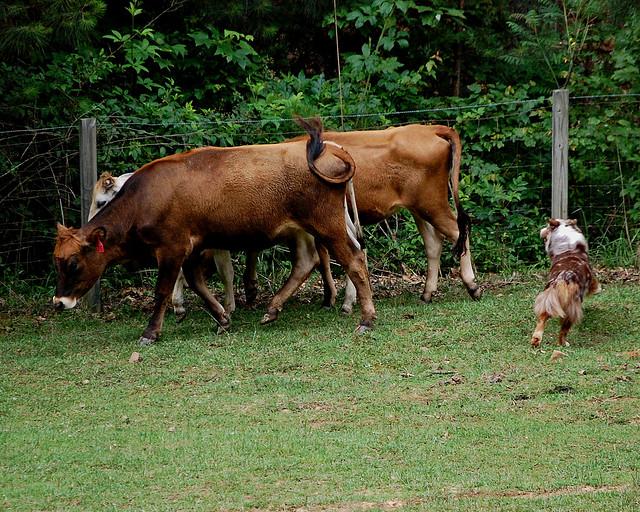Are these two cows eating grass?
Answer briefly. Yes. Is there a fence that contains these cows?
Quick response, please. Yes. Does any animal have antlers?
Short answer required. No. What sex is the cow closest to the fence?
Quick response, please. Female. How many baby buffalo are in this picture?
Short answer required. 0. What color are the cows?
Keep it brief. Brown. Could the dog be herding?
Give a very brief answer. Yes. 